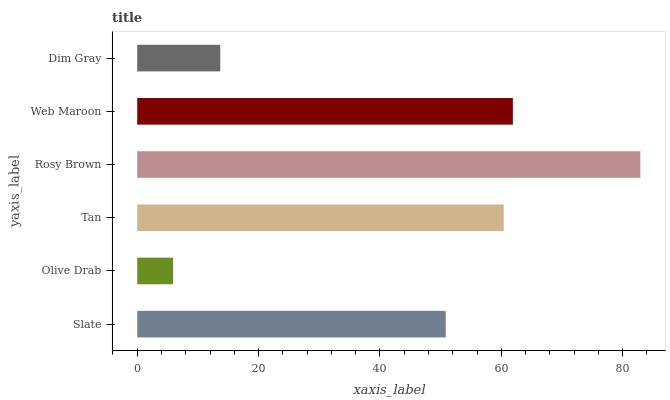Is Olive Drab the minimum?
Answer yes or no. Yes. Is Rosy Brown the maximum?
Answer yes or no. Yes. Is Tan the minimum?
Answer yes or no. No. Is Tan the maximum?
Answer yes or no. No. Is Tan greater than Olive Drab?
Answer yes or no. Yes. Is Olive Drab less than Tan?
Answer yes or no. Yes. Is Olive Drab greater than Tan?
Answer yes or no. No. Is Tan less than Olive Drab?
Answer yes or no. No. Is Tan the high median?
Answer yes or no. Yes. Is Slate the low median?
Answer yes or no. Yes. Is Rosy Brown the high median?
Answer yes or no. No. Is Olive Drab the low median?
Answer yes or no. No. 